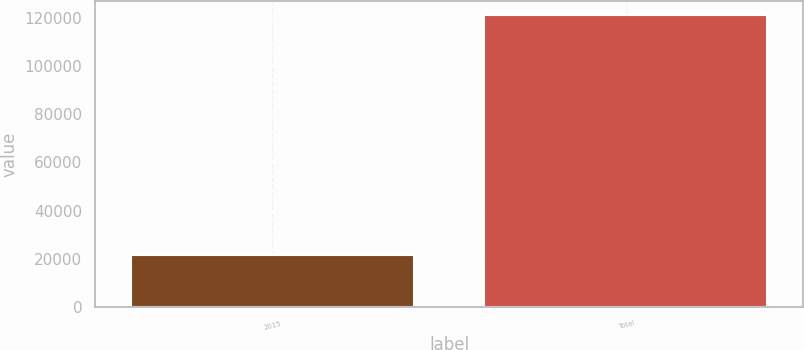Convert chart to OTSL. <chart><loc_0><loc_0><loc_500><loc_500><bar_chart><fcel>2015<fcel>Total<nl><fcel>21505<fcel>121006<nl></chart> 